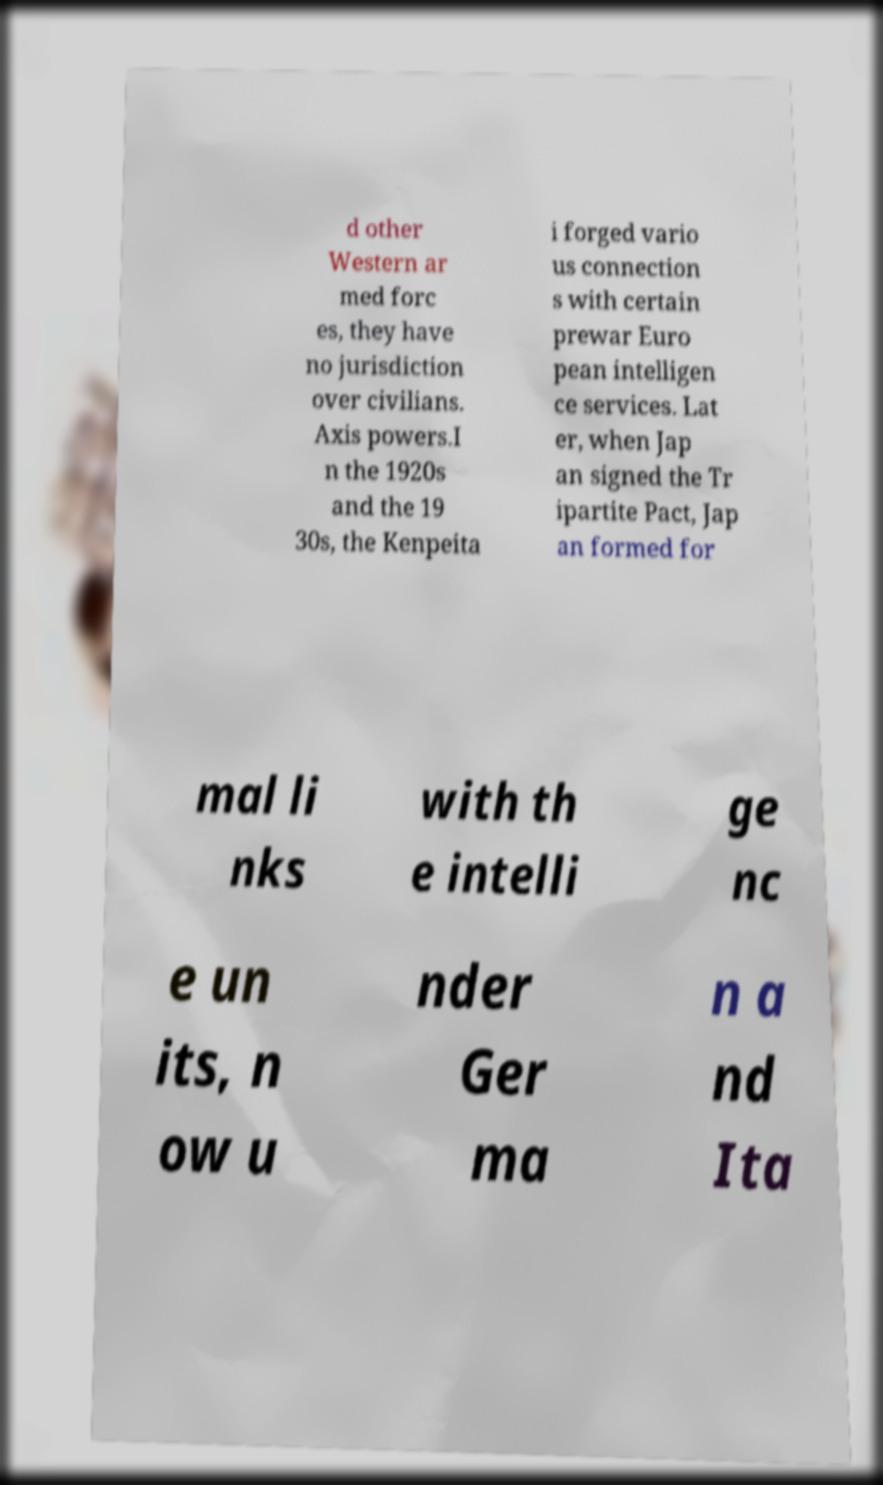Could you assist in decoding the text presented in this image and type it out clearly? d other Western ar med forc es, they have no jurisdiction over civilians. Axis powers.I n the 1920s and the 19 30s, the Kenpeita i forged vario us connection s with certain prewar Euro pean intelligen ce services. Lat er, when Jap an signed the Tr ipartite Pact, Jap an formed for mal li nks with th e intelli ge nc e un its, n ow u nder Ger ma n a nd Ita 